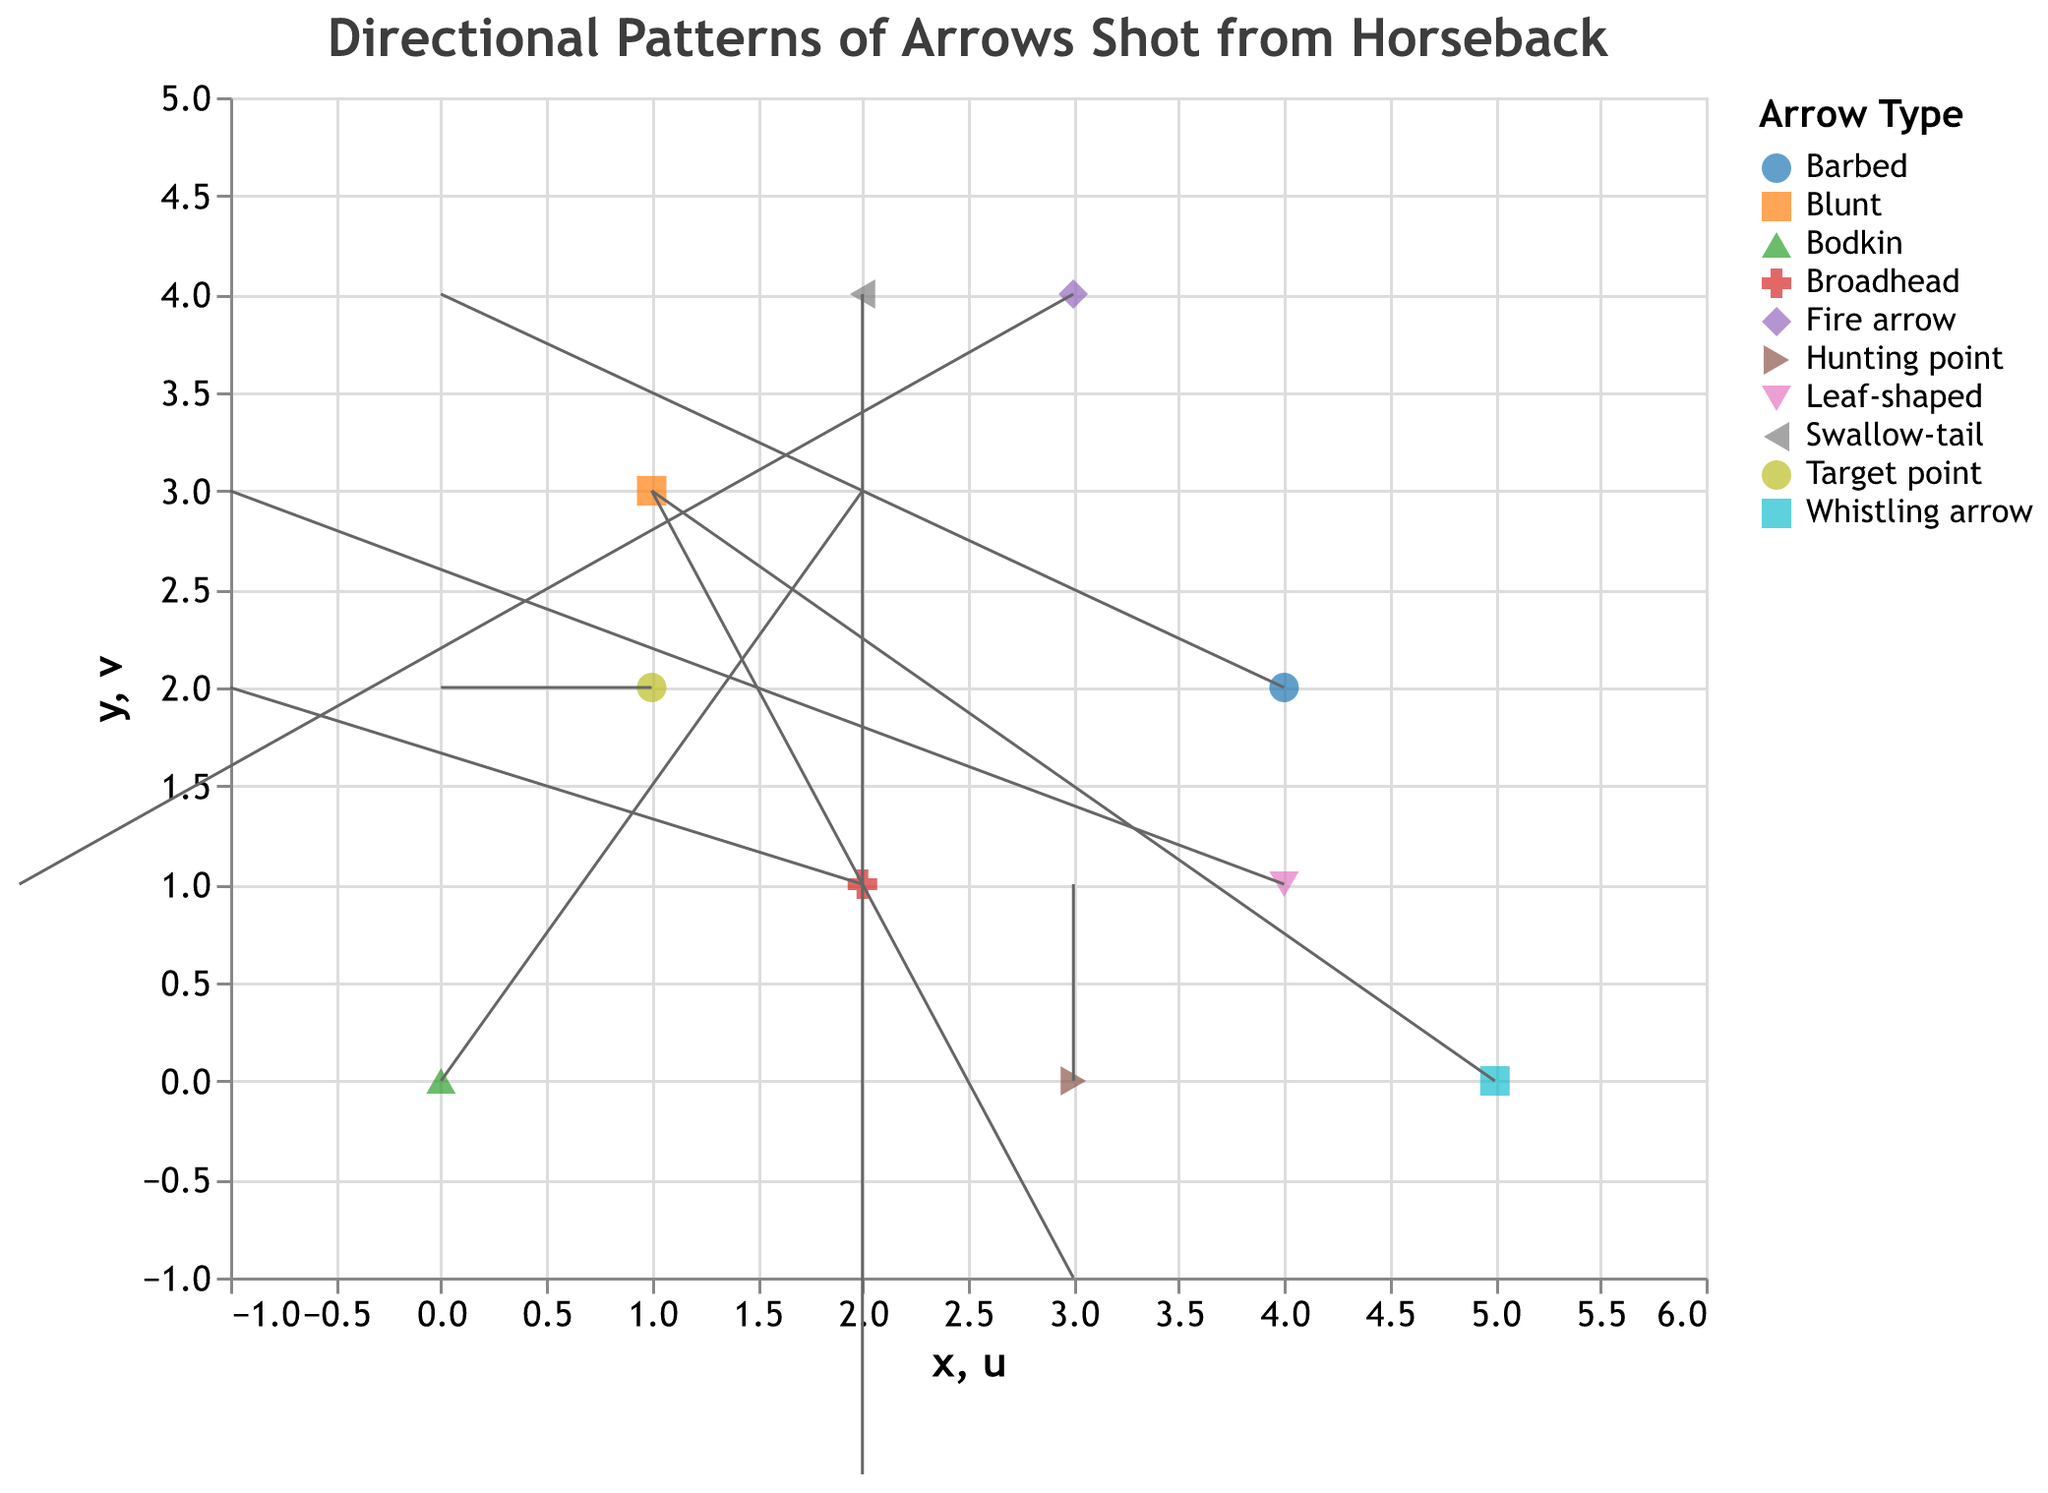How many different types of arrows are represented in the plot? By counting the different arrow types listed in the legend: Bodkin, Broadhead, Barbed, Blunt, Fire arrow, Whistling arrow, Swallow-tail, Leaf-shaped, Target point, and Hunting point, there are 10 types.
Answer: 10 What is the title of the plot? The title is specified at the top of the plot.
Answer: Directional Patterns of Arrows Shot from Horseback Which arrow immediately stands out due to its unique path direction in the plot? The Barbed arrow stands out because it moves directly vertically (u=0, v=4).
Answer: Barbed Which two arrows have the highest speed and what are their speeds? By examining the speed values in the tooltips, the Fire arrow has a speed of 30, and the Hunting point has a speed of 35.
Answer: Fire arrow (30), Hunting point (35) Which arrow type shows the least movement in the horizontal direction? The Target point has u=0, indicating no movement horizontally.
Answer: Target point Compare the direction vectors of the Bodkin and Broadhead arrows. Which arrow has a greater vertical movement? The Bodkin arrow has a vertical component v=3, while the Broadhead arrow has v=2. Therefore, the Bodkin arrow has a greater vertical movement.
Answer: Bodkin Calculate the average speed of all arrows. Add the speeds: 15 + 20 + 25 + 10 + 30 + 18 + 22 + 28 + 12 + 35 = 215. The number of arrows is 10, so average speed = 215 / 10 = 21.5.
Answer: 21.5 Identify the arrow with the greatest horizontal movement, either positive or negative. By comparing absolute values of u from the plot, the Blunt arrow has the greatest horizontal movement with u=3.
Answer: Blunt Do any arrows have both horizontal and vertical movements equal in magnitude? The Swallow-tail arrow (u=2, v=-2) has equal horizontal and vertical movement magnitudes, but in opposite directions.
Answer: Swallow-tail 